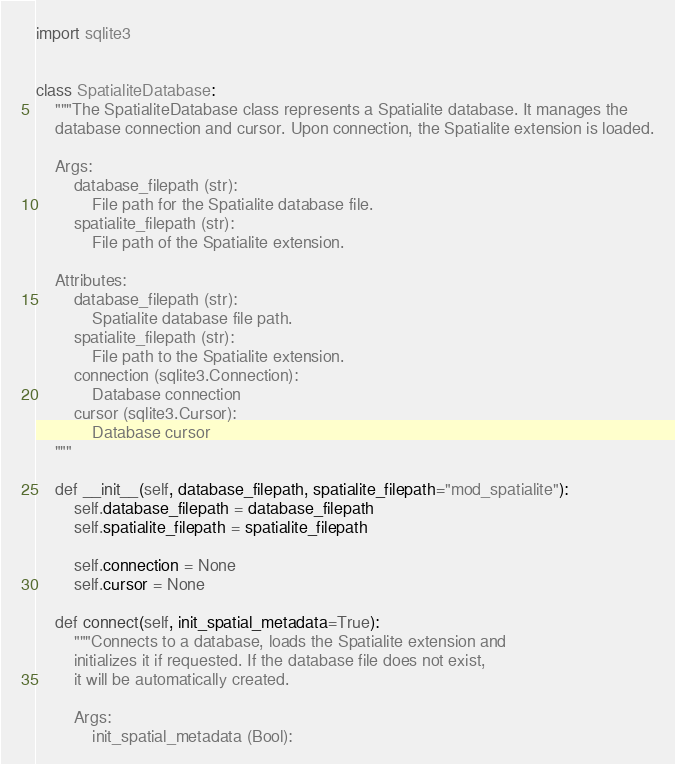<code> <loc_0><loc_0><loc_500><loc_500><_Python_>import sqlite3


class SpatialiteDatabase:
    """The SpatialiteDatabase class represents a Spatialite database. It manages the
    database connection and cursor. Upon connection, the Spatialite extension is loaded.

    Args:
        database_filepath (str):
            File path for the Spatialite database file.
        spatialite_filepath (str):
            File path of the Spatialite extension.

    Attributes:
        database_filepath (str):
            Spatialite database file path.
        spatialite_filepath (str):
            File path to the Spatialite extension.
        connection (sqlite3.Connection):
            Database connection
        cursor (sqlite3.Cursor):
            Database cursor
    """

    def __init__(self, database_filepath, spatialite_filepath="mod_spatialite"):
        self.database_filepath = database_filepath
        self.spatialite_filepath = spatialite_filepath

        self.connection = None
        self.cursor = None

    def connect(self, init_spatial_metadata=True):
        """Connects to a database, loads the Spatialite extension and
        initializes it if requested. If the database file does not exist,
        it will be automatically created.

        Args:
            init_spatial_metadata (Bool):</code> 